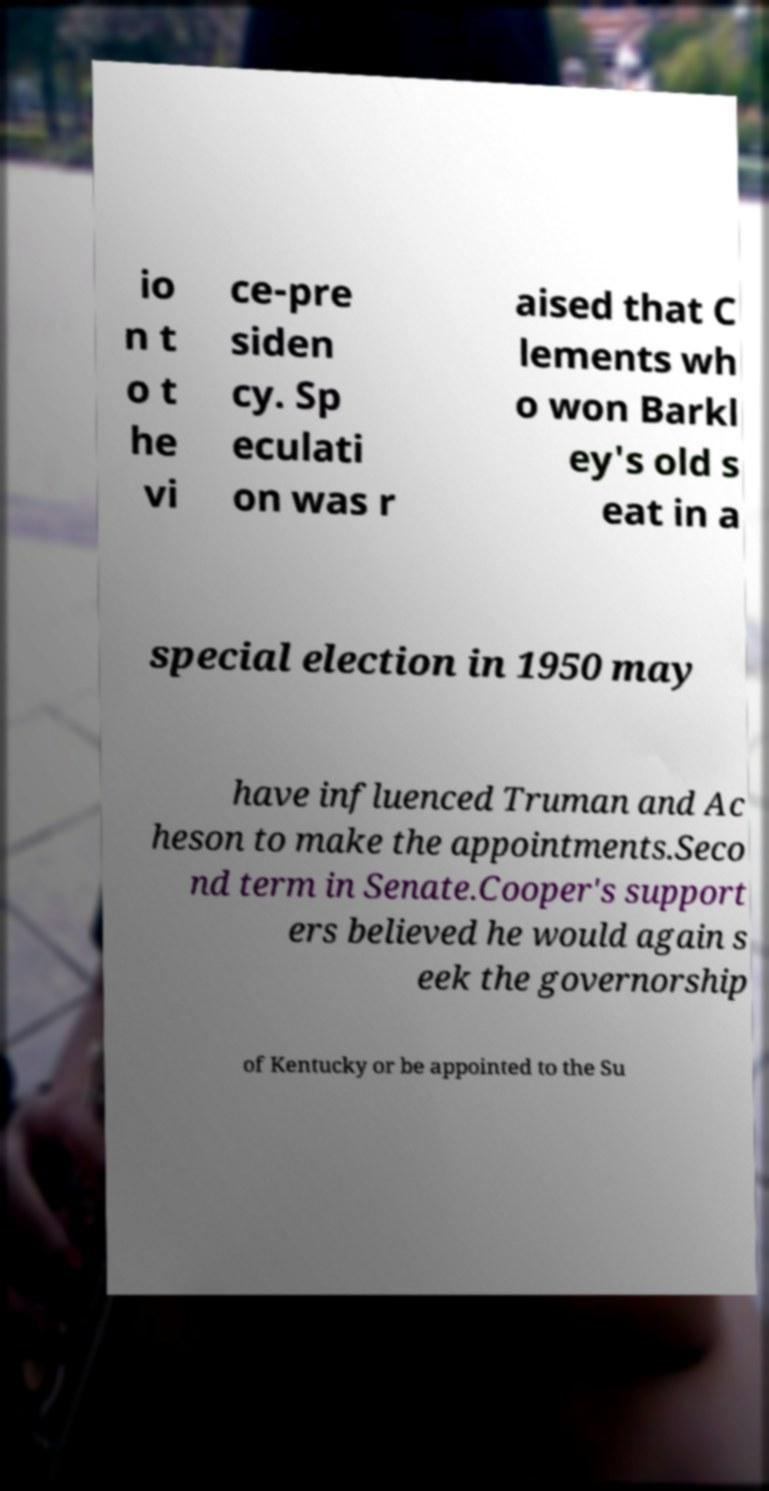Can you read and provide the text displayed in the image?This photo seems to have some interesting text. Can you extract and type it out for me? io n t o t he vi ce-pre siden cy. Sp eculati on was r aised that C lements wh o won Barkl ey's old s eat in a special election in 1950 may have influenced Truman and Ac heson to make the appointments.Seco nd term in Senate.Cooper's support ers believed he would again s eek the governorship of Kentucky or be appointed to the Su 